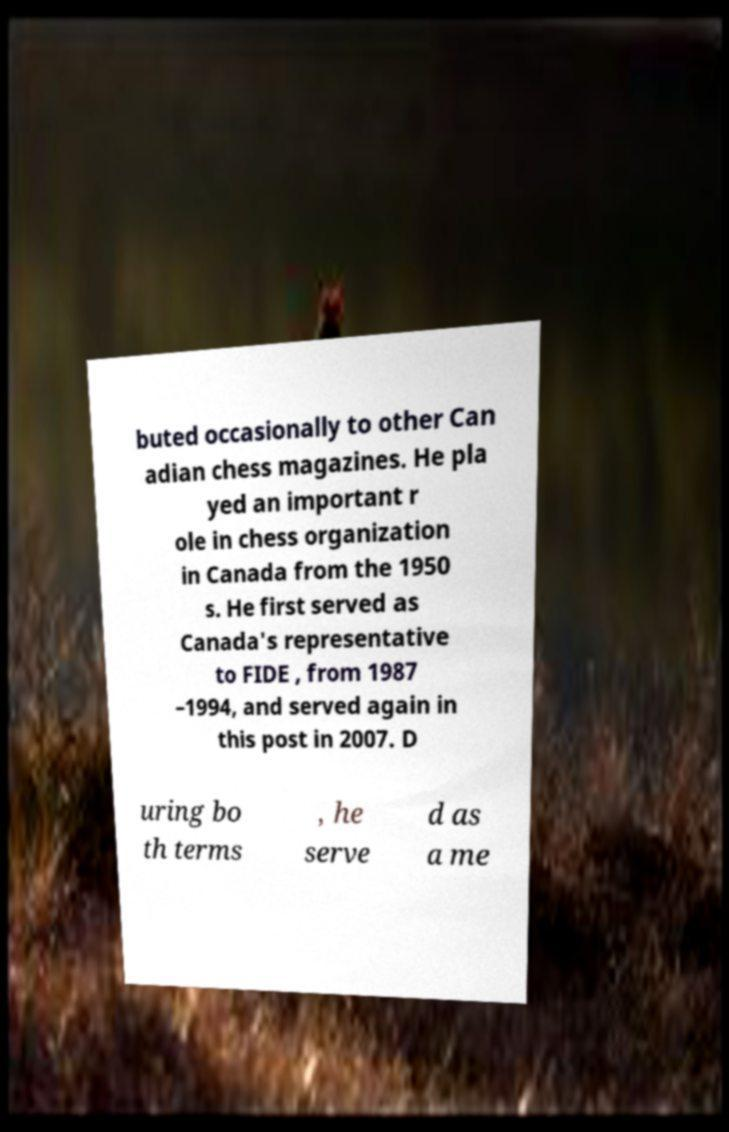What messages or text are displayed in this image? I need them in a readable, typed format. buted occasionally to other Can adian chess magazines. He pla yed an important r ole in chess organization in Canada from the 1950 s. He first served as Canada's representative to FIDE , from 1987 –1994, and served again in this post in 2007. D uring bo th terms , he serve d as a me 